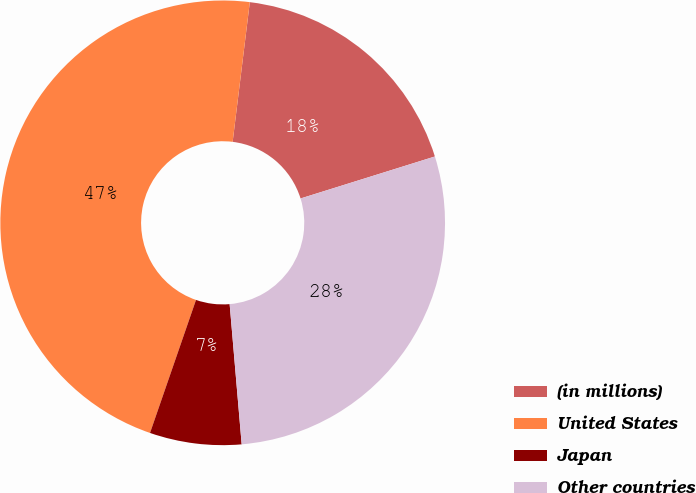<chart> <loc_0><loc_0><loc_500><loc_500><pie_chart><fcel>(in millions)<fcel>United States<fcel>Japan<fcel>Other countries<nl><fcel>18.23%<fcel>46.65%<fcel>6.66%<fcel>28.46%<nl></chart> 